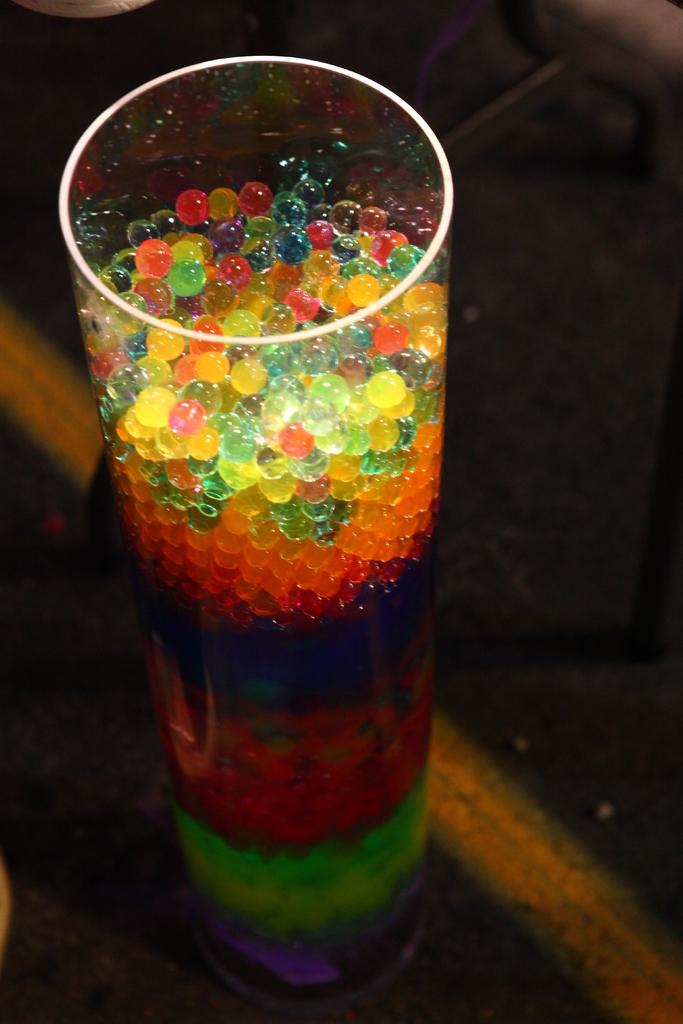What is on the ground in the image? There is a glass on the ground in the image. What is inside the glass? There are objects inside the glass. Can you describe the object that appears to be truncated towards the top of the image? Unfortunately, the provided facts do not give enough information to describe the truncated object. How many vegetables are being kicked by the scarecrow in the image? There is no scarecrow or vegetables present in the image. 